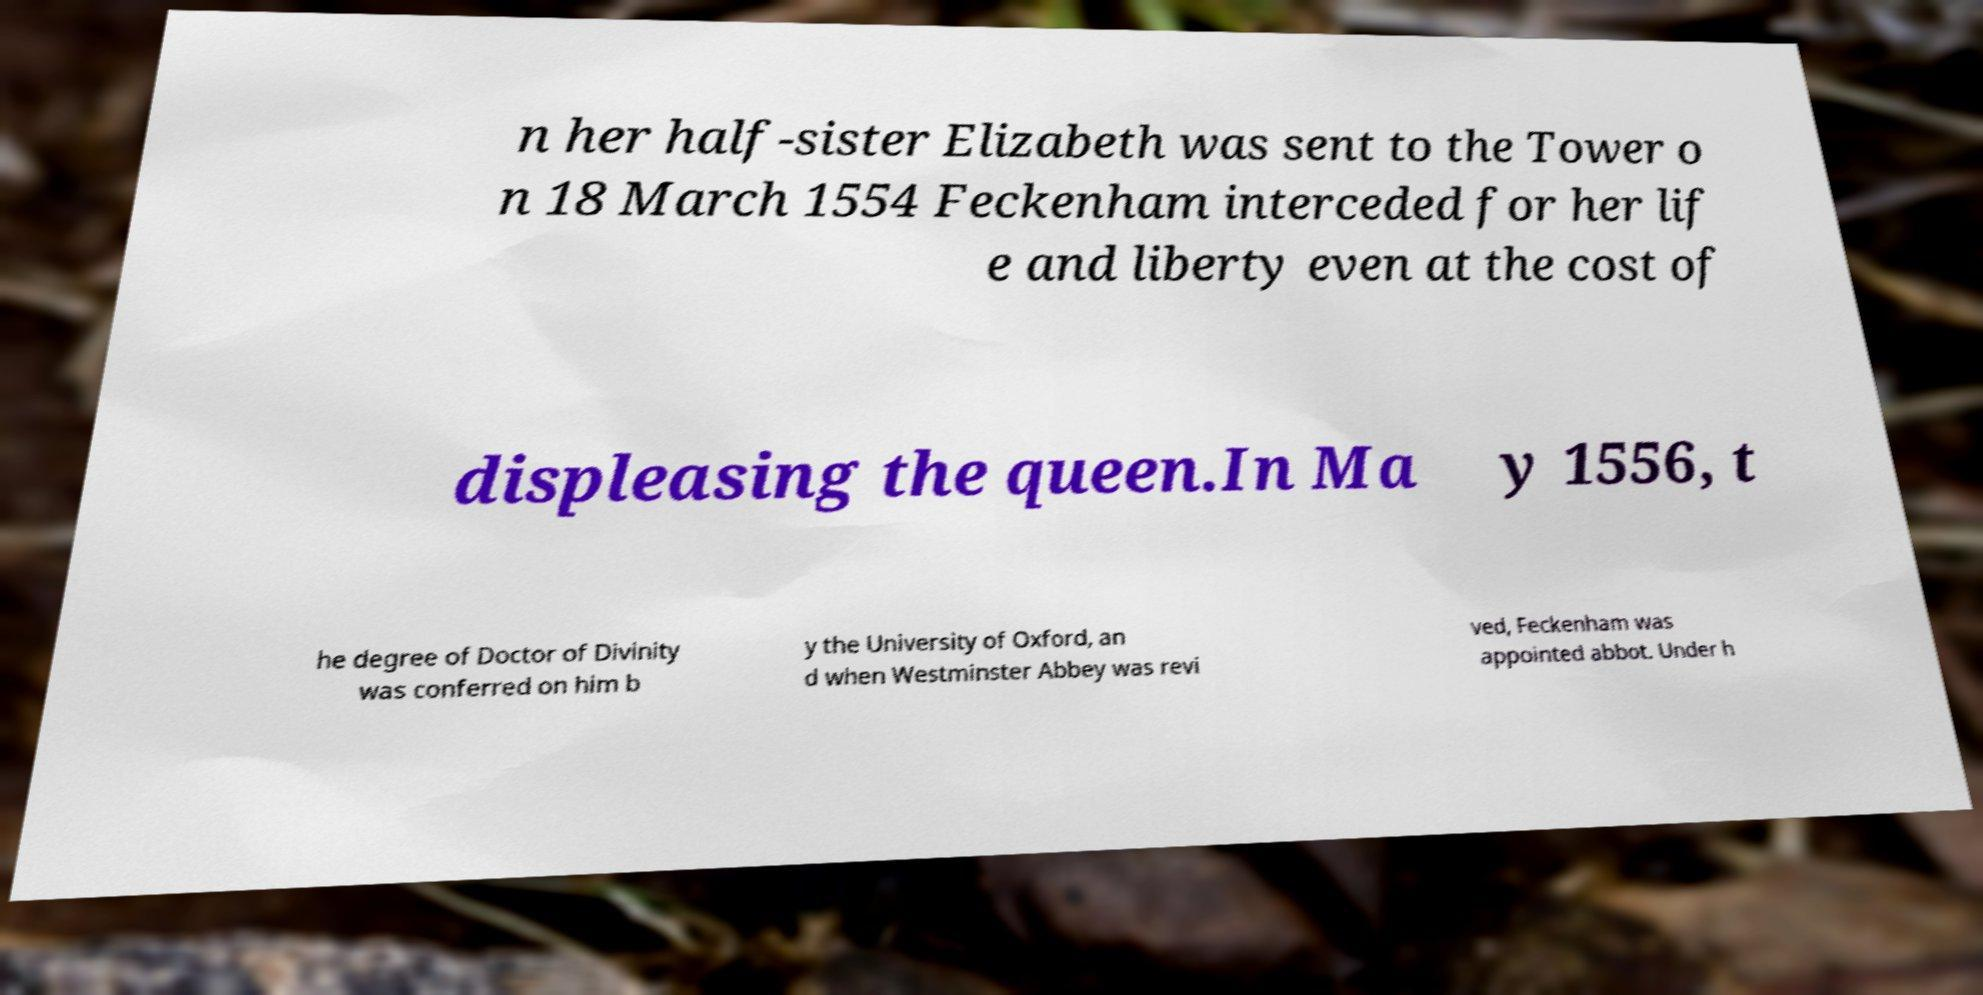For documentation purposes, I need the text within this image transcribed. Could you provide that? n her half-sister Elizabeth was sent to the Tower o n 18 March 1554 Feckenham interceded for her lif e and liberty even at the cost of displeasing the queen.In Ma y 1556, t he degree of Doctor of Divinity was conferred on him b y the University of Oxford, an d when Westminster Abbey was revi ved, Feckenham was appointed abbot. Under h 